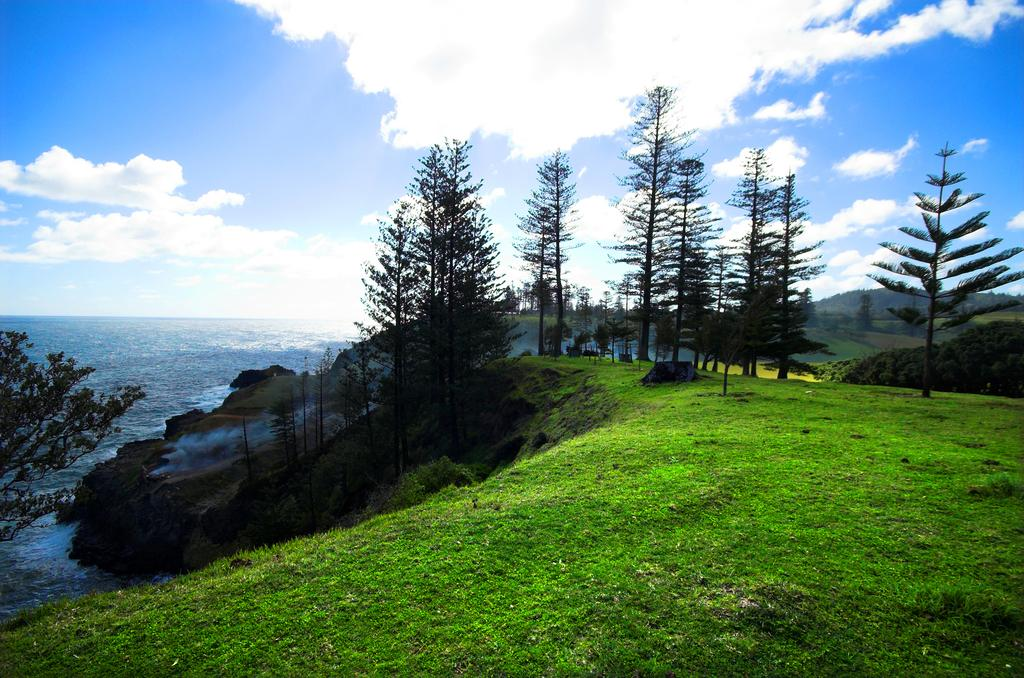What type of landscape is depicted in the image? There is a grassland in the image. What other natural features can be seen in the image? There are trees and a sea in the image. What is visible in the sky in the image? The sky is visible in the image. What type of net is being used by the farmer in the image? There is no farmer or net present in the image. What thrilling activity is taking place in the image? There is no thrilling activity depicted in the image; it features a grassland, trees, a sea, and the sky. 